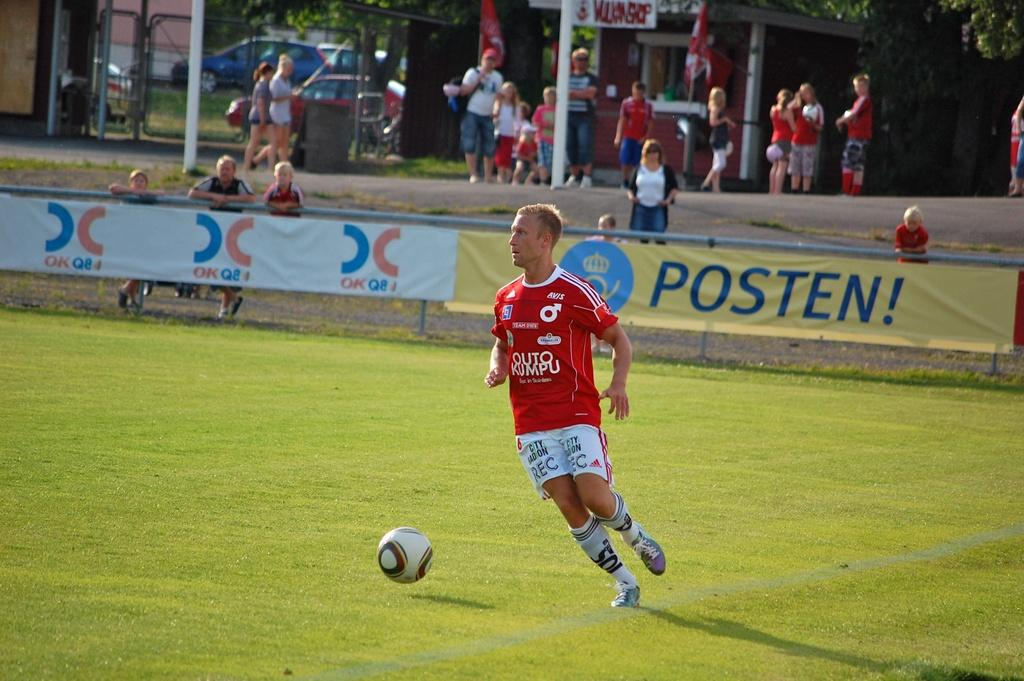<image>
Describe the image concisely. A blond man wearing a red Outo Kumpu jersey with a soccer ball on a green field with a sign saying Posten! behind him 